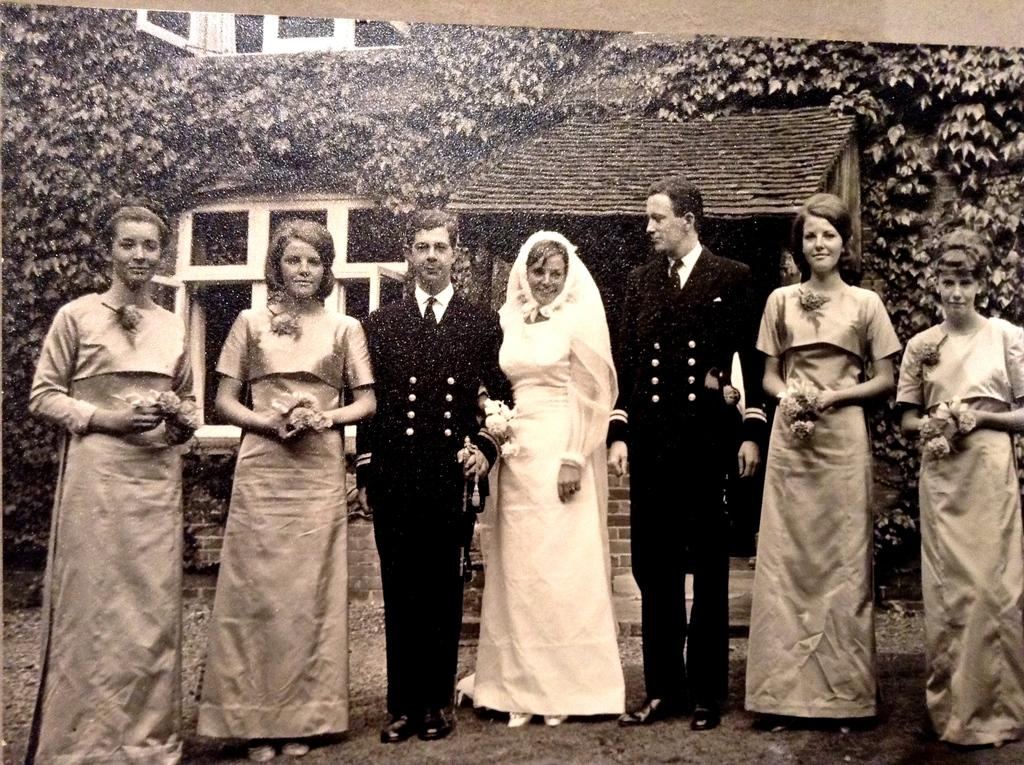What is the color scheme of the image? The image is black and white. What can be seen in the foreground of the image? There are people standing in the image. What is visible in the background of the image? There is a house and trees in the background of the image. What type of fruit is being valued by the women in the image? There are no women or fruit present in the image. 